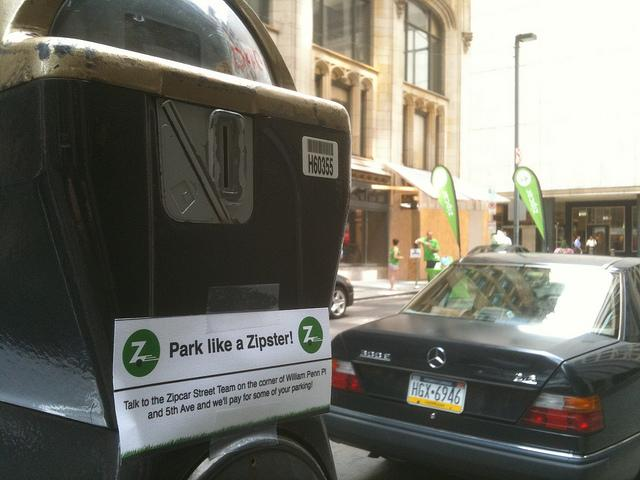What make of car can be seen next to the parking meter? Please explain your reasoning. mercedes. An older, boxy mercedes is parked by the meter. 